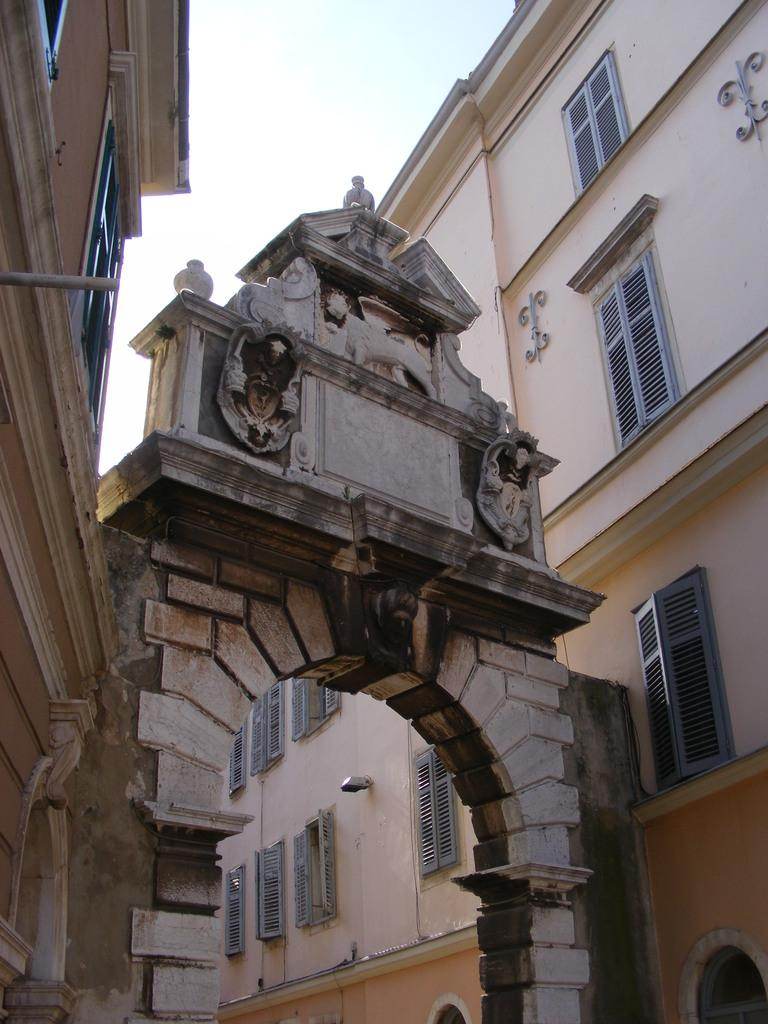What type of structures can be seen in the image? There are buildings in the image. What architectural feature is present in the image? There is an arch in the image. What is the condition of the sky in the image? The sky is cloudy in the image. What type of mountain can be seen in the image? There is no mountain present in the image; it features buildings and an arch. What is the interest rate on the tank in the image? There is no tank present in the image, and therefore no interest rate can be determined. 